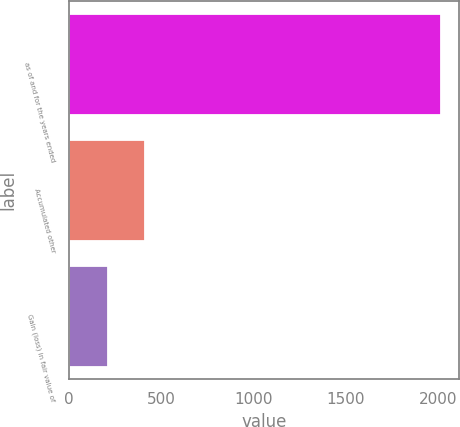Convert chart. <chart><loc_0><loc_0><loc_500><loc_500><bar_chart><fcel>as of and for the years ended<fcel>Accumulated other<fcel>Gain (loss) in fair value of<nl><fcel>2014<fcel>410.8<fcel>210.4<nl></chart> 